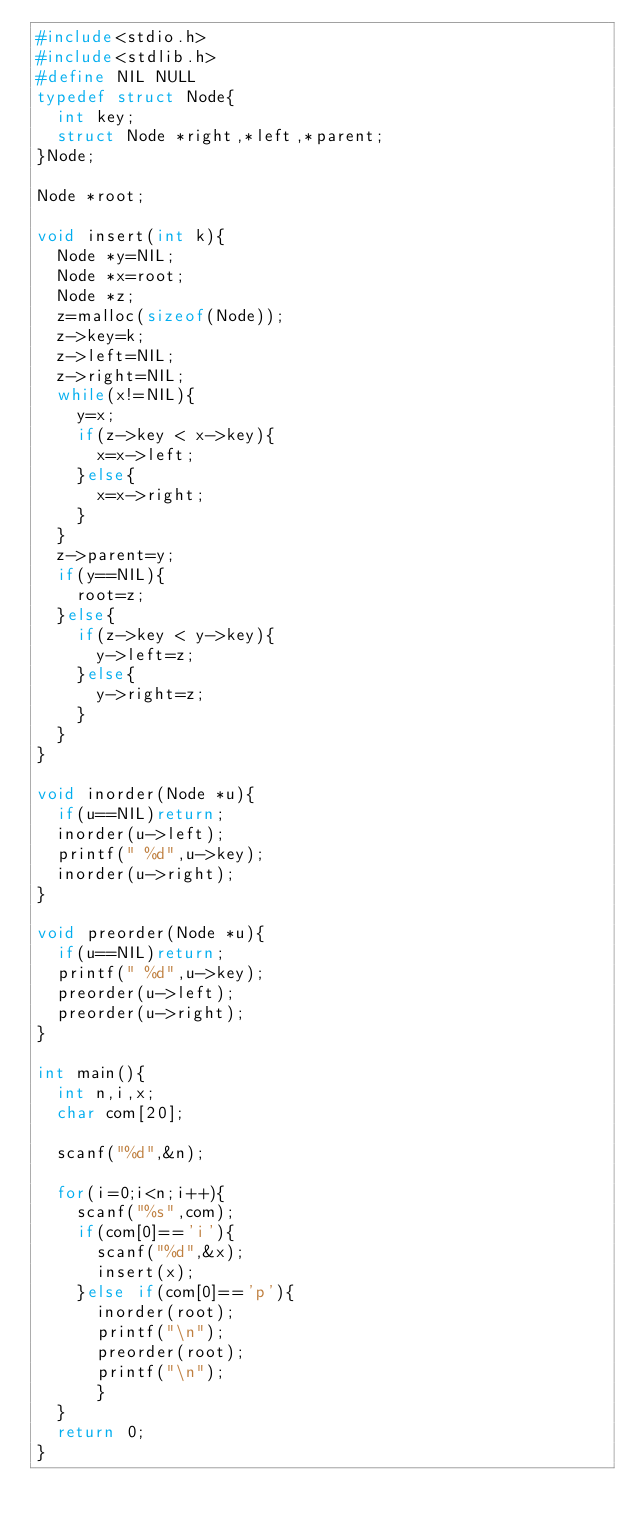<code> <loc_0><loc_0><loc_500><loc_500><_C_>#include<stdio.h>
#include<stdlib.h>
#define NIL NULL
typedef struct Node{
  int key;
  struct Node *right,*left,*parent;
}Node;

Node *root;

void insert(int k){
  Node *y=NIL;
  Node *x=root;
  Node *z;
  z=malloc(sizeof(Node));
  z->key=k;
  z->left=NIL;
  z->right=NIL;
  while(x!=NIL){
    y=x;
    if(z->key < x->key){
      x=x->left;
    }else{
      x=x->right;
    }
  }
  z->parent=y;
  if(y==NIL){
    root=z;
  }else{
    if(z->key < y->key){
      y->left=z;
    }else{
      y->right=z;
    }
  }
}

void inorder(Node *u){
  if(u==NIL)return;
  inorder(u->left);
  printf(" %d",u->key);
  inorder(u->right);
}

void preorder(Node *u){
  if(u==NIL)return;
  printf(" %d",u->key);
  preorder(u->left);
  preorder(u->right);
}

int main(){
  int n,i,x;
  char com[20];

  scanf("%d",&n);

  for(i=0;i<n;i++){
    scanf("%s",com);
    if(com[0]=='i'){
      scanf("%d",&x);
      insert(x);
    }else if(com[0]=='p'){
      inorder(root);
      printf("\n");
      preorder(root);
      printf("\n");
      }
  }
  return 0;
}</code> 